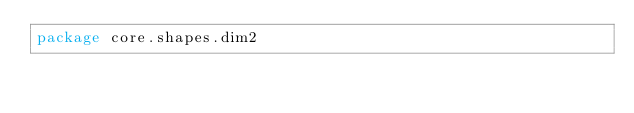<code> <loc_0><loc_0><loc_500><loc_500><_Scala_>package core.shapes.dim2
</code> 